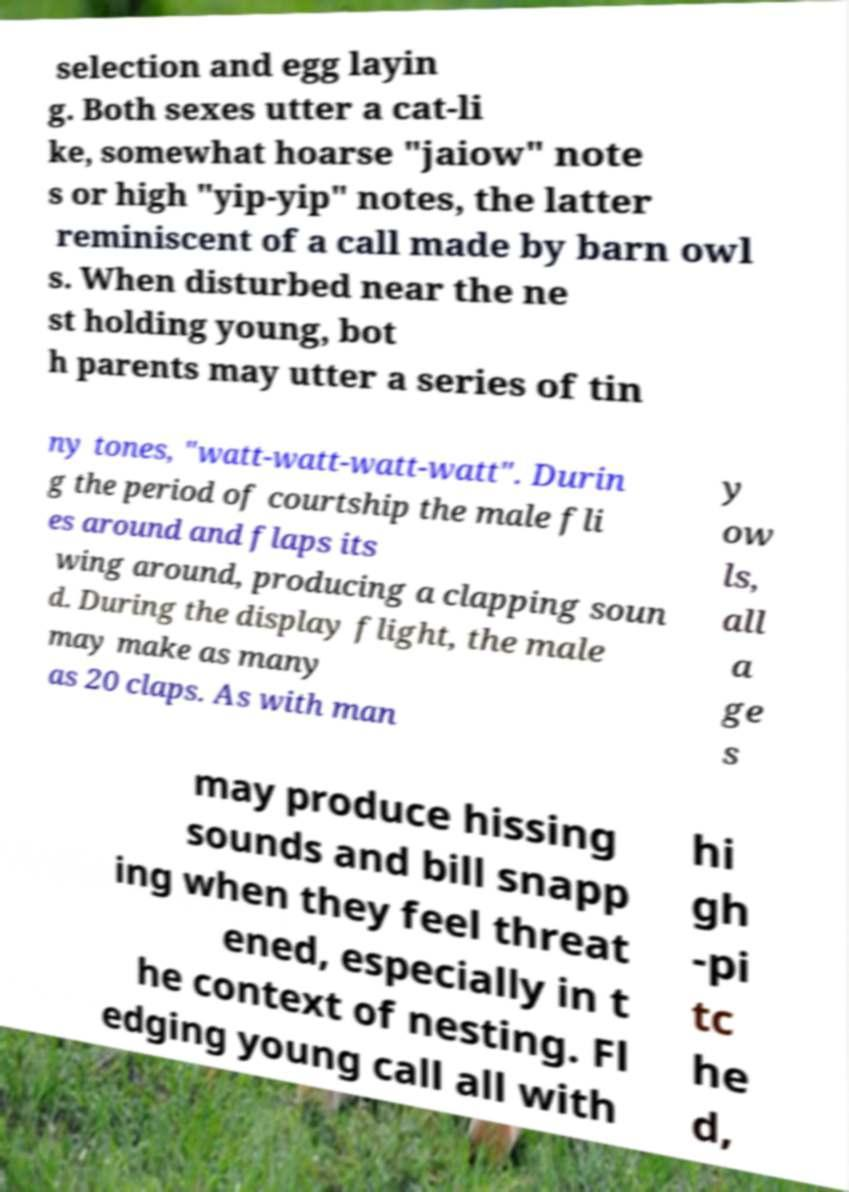Please read and relay the text visible in this image. What does it say? selection and egg layin g. Both sexes utter a cat-li ke, somewhat hoarse "jaiow" note s or high "yip-yip" notes, the latter reminiscent of a call made by barn owl s. When disturbed near the ne st holding young, bot h parents may utter a series of tin ny tones, "watt-watt-watt-watt". Durin g the period of courtship the male fli es around and flaps its wing around, producing a clapping soun d. During the display flight, the male may make as many as 20 claps. As with man y ow ls, all a ge s may produce hissing sounds and bill snapp ing when they feel threat ened, especially in t he context of nesting. Fl edging young call all with hi gh -pi tc he d, 